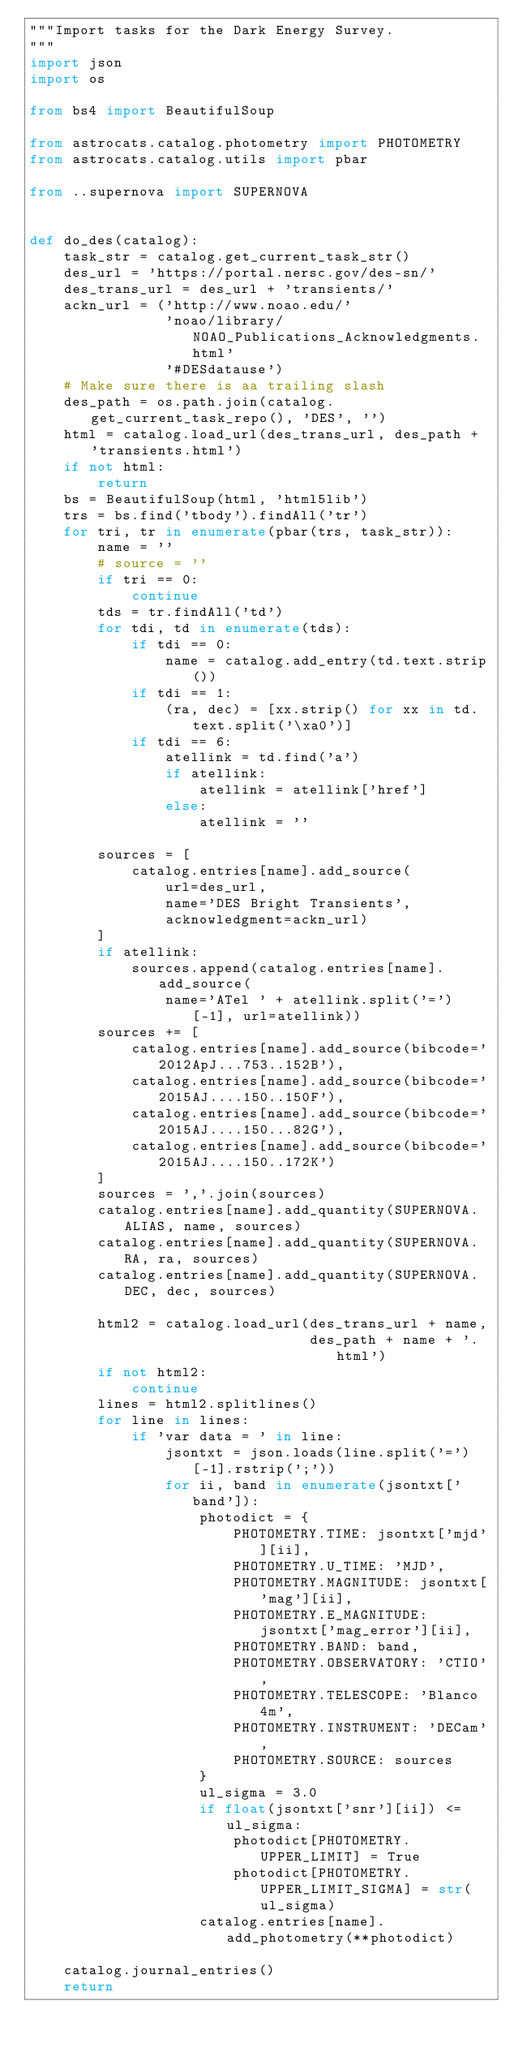Convert code to text. <code><loc_0><loc_0><loc_500><loc_500><_Python_>"""Import tasks for the Dark Energy Survey.
"""
import json
import os

from bs4 import BeautifulSoup

from astrocats.catalog.photometry import PHOTOMETRY
from astrocats.catalog.utils import pbar

from ..supernova import SUPERNOVA


def do_des(catalog):
    task_str = catalog.get_current_task_str()
    des_url = 'https://portal.nersc.gov/des-sn/'
    des_trans_url = des_url + 'transients/'
    ackn_url = ('http://www.noao.edu/'
                'noao/library/NOAO_Publications_Acknowledgments.html'
                '#DESdatause')
    # Make sure there is aa trailing slash
    des_path = os.path.join(catalog.get_current_task_repo(), 'DES', '')
    html = catalog.load_url(des_trans_url, des_path + 'transients.html')
    if not html:
        return
    bs = BeautifulSoup(html, 'html5lib')
    trs = bs.find('tbody').findAll('tr')
    for tri, tr in enumerate(pbar(trs, task_str)):
        name = ''
        # source = ''
        if tri == 0:
            continue
        tds = tr.findAll('td')
        for tdi, td in enumerate(tds):
            if tdi == 0:
                name = catalog.add_entry(td.text.strip())
            if tdi == 1:
                (ra, dec) = [xx.strip() for xx in td.text.split('\xa0')]
            if tdi == 6:
                atellink = td.find('a')
                if atellink:
                    atellink = atellink['href']
                else:
                    atellink = ''

        sources = [
            catalog.entries[name].add_source(
                url=des_url,
                name='DES Bright Transients',
                acknowledgment=ackn_url)
        ]
        if atellink:
            sources.append(catalog.entries[name].add_source(
                name='ATel ' + atellink.split('=')[-1], url=atellink))
        sources += [
            catalog.entries[name].add_source(bibcode='2012ApJ...753..152B'),
            catalog.entries[name].add_source(bibcode='2015AJ....150..150F'),
            catalog.entries[name].add_source(bibcode='2015AJ....150...82G'),
            catalog.entries[name].add_source(bibcode='2015AJ....150..172K')
        ]
        sources = ','.join(sources)
        catalog.entries[name].add_quantity(SUPERNOVA.ALIAS, name, sources)
        catalog.entries[name].add_quantity(SUPERNOVA.RA, ra, sources)
        catalog.entries[name].add_quantity(SUPERNOVA.DEC, dec, sources)

        html2 = catalog.load_url(des_trans_url + name,
                                 des_path + name + '.html')
        if not html2:
            continue
        lines = html2.splitlines()
        for line in lines:
            if 'var data = ' in line:
                jsontxt = json.loads(line.split('=')[-1].rstrip(';'))
                for ii, band in enumerate(jsontxt['band']):
                    photodict = {
                        PHOTOMETRY.TIME: jsontxt['mjd'][ii],
                        PHOTOMETRY.U_TIME: 'MJD',
                        PHOTOMETRY.MAGNITUDE: jsontxt['mag'][ii],
                        PHOTOMETRY.E_MAGNITUDE: jsontxt['mag_error'][ii],
                        PHOTOMETRY.BAND: band,
                        PHOTOMETRY.OBSERVATORY: 'CTIO',
                        PHOTOMETRY.TELESCOPE: 'Blanco 4m',
                        PHOTOMETRY.INSTRUMENT: 'DECam',
                        PHOTOMETRY.SOURCE: sources
                    }
                    ul_sigma = 3.0
                    if float(jsontxt['snr'][ii]) <= ul_sigma:
                        photodict[PHOTOMETRY.UPPER_LIMIT] = True
                        photodict[PHOTOMETRY.UPPER_LIMIT_SIGMA] = str(ul_sigma)
                    catalog.entries[name].add_photometry(**photodict)

    catalog.journal_entries()
    return
</code> 